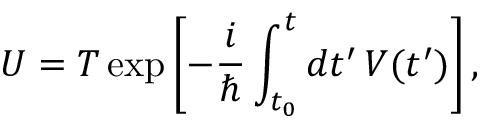Convert formula to latex. <formula><loc_0><loc_0><loc_500><loc_500>U = T \exp \left [ - { \frac { i } { } } \int _ { t _ { 0 } } ^ { t } d t ^ { \prime } \, V ( t ^ { \prime } ) \right ] ,</formula> 